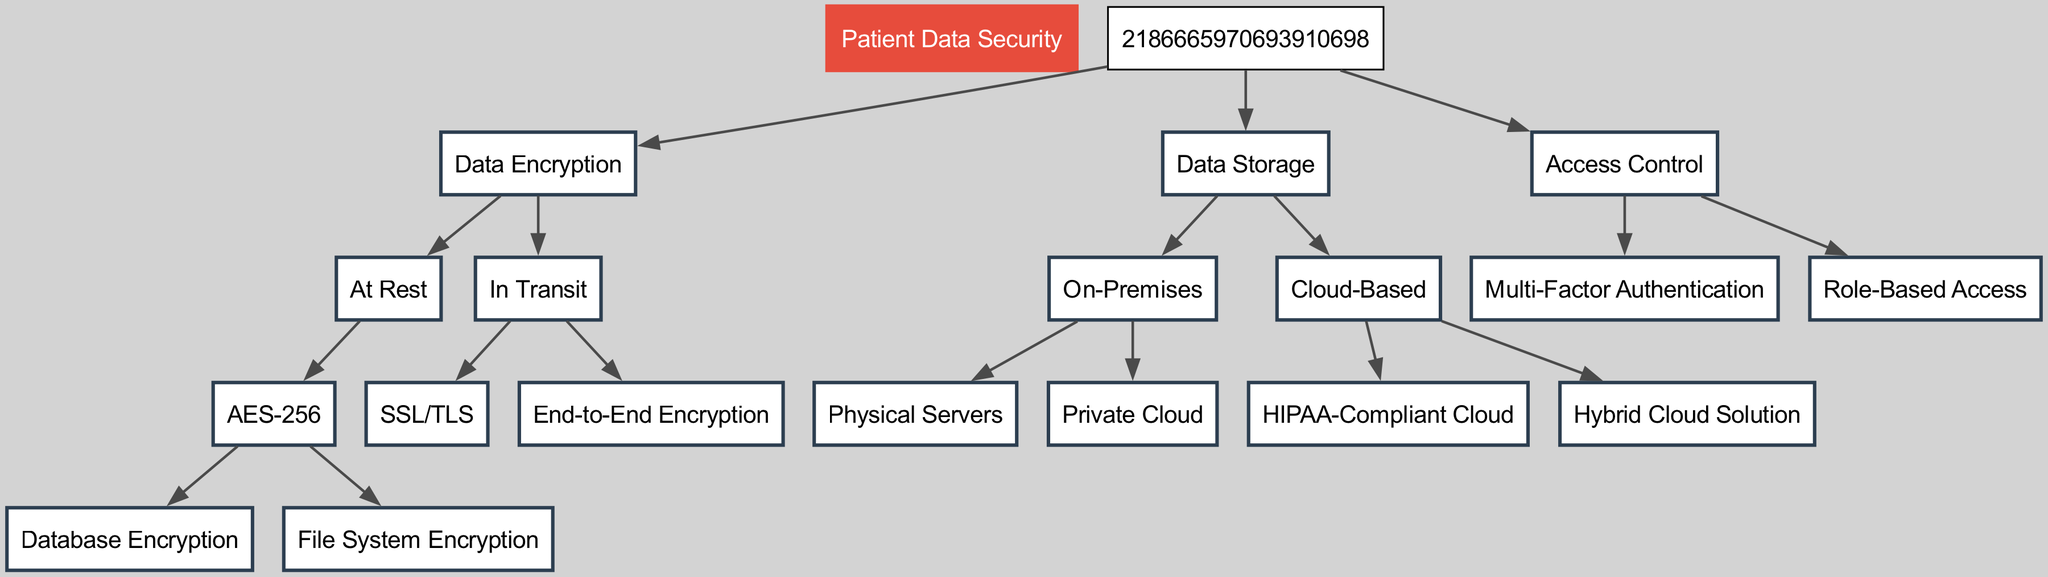What is the root node of the diagram? The root node is indicated at the top of the diagram as "Patient Data Security," which serves as the starting point for all subsequent nodes.
Answer: Patient Data Security How many main categories are in the diagram? The diagram splits into three primary categories: Data Encryption, Data Storage, and Access Control, which are directly connected to the root node.
Answer: Three What encryption method is used for data at rest? The method specified for data at rest in the diagram is "AES-256," indicating a standard for encrypting data stored on devices or servers.
Answer: AES-256 Which encryption protocols are used for data in transit? The diagram lists "SSL/TLS" and "End-to-End Encryption" as the two protocols employed to protect data while it is being transmitted over a network.
Answer: SSL/TLS, End-to-End Encryption What are the subcategories under Data Storage? Under Data Storage, there are two main subcategories: "On-Premises" and "Cloud-Based," indicating the different options for storing data.
Answer: On-Premises, Cloud-Based What is the storage option directly related to HIPAA compliance? The specific option mentioned in the diagram for HIPAA compliance is "HIPAA-Compliant Cloud," showing adherence to legal patient data handling requirements.
Answer: HIPAA-Compliant Cloud Which access control method emphasizes user role definitions? The access control method that focuses on defining roles for users is "Role-Based Access," ensuring that users have access only to what they are authorized for.
Answer: Role-Based Access How many encryption methods are shown for data at rest? The diagram indicates that there are two methods of encryption for data at rest: "Database Encryption" and "File System Encryption," both falling under the AES-256 category.
Answer: Two What type of servers are included in the On-Premises category? The On-Premises category specifically includes "Physical Servers," highlighting one of the storage solutions for patient data within the organization's infrastructure.
Answer: Physical Servers 